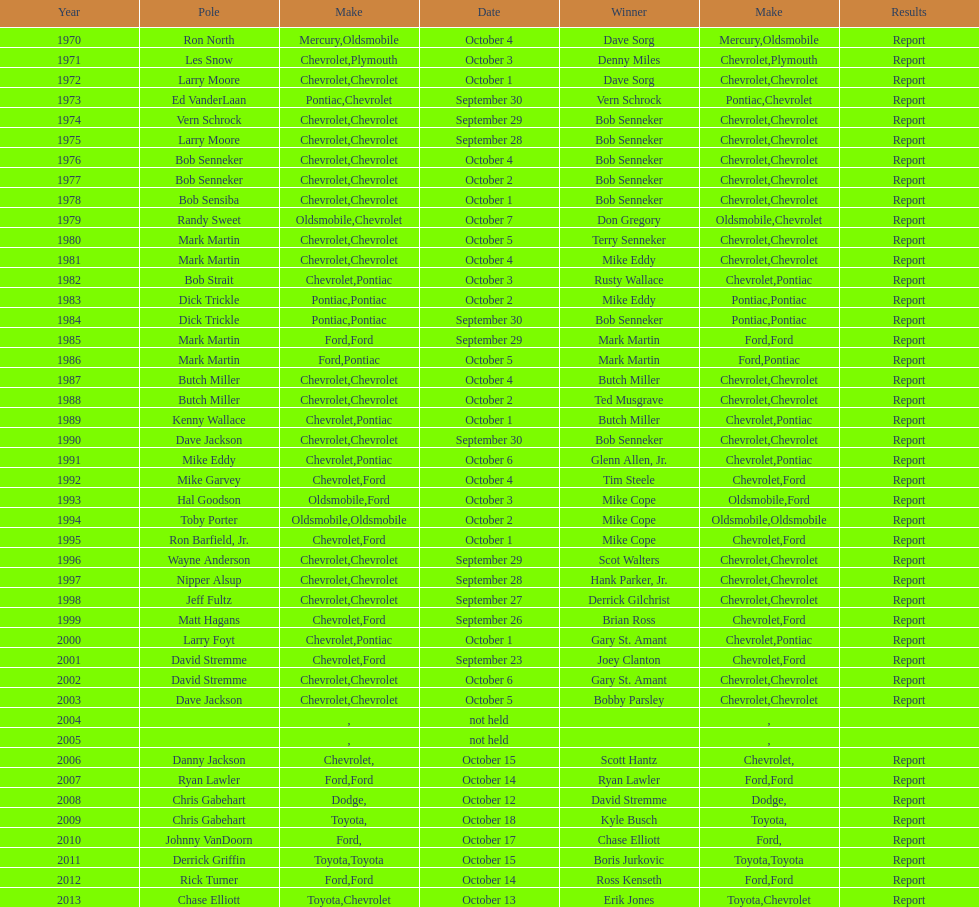How many winning oldsmobile vehicles made the list? 3. 